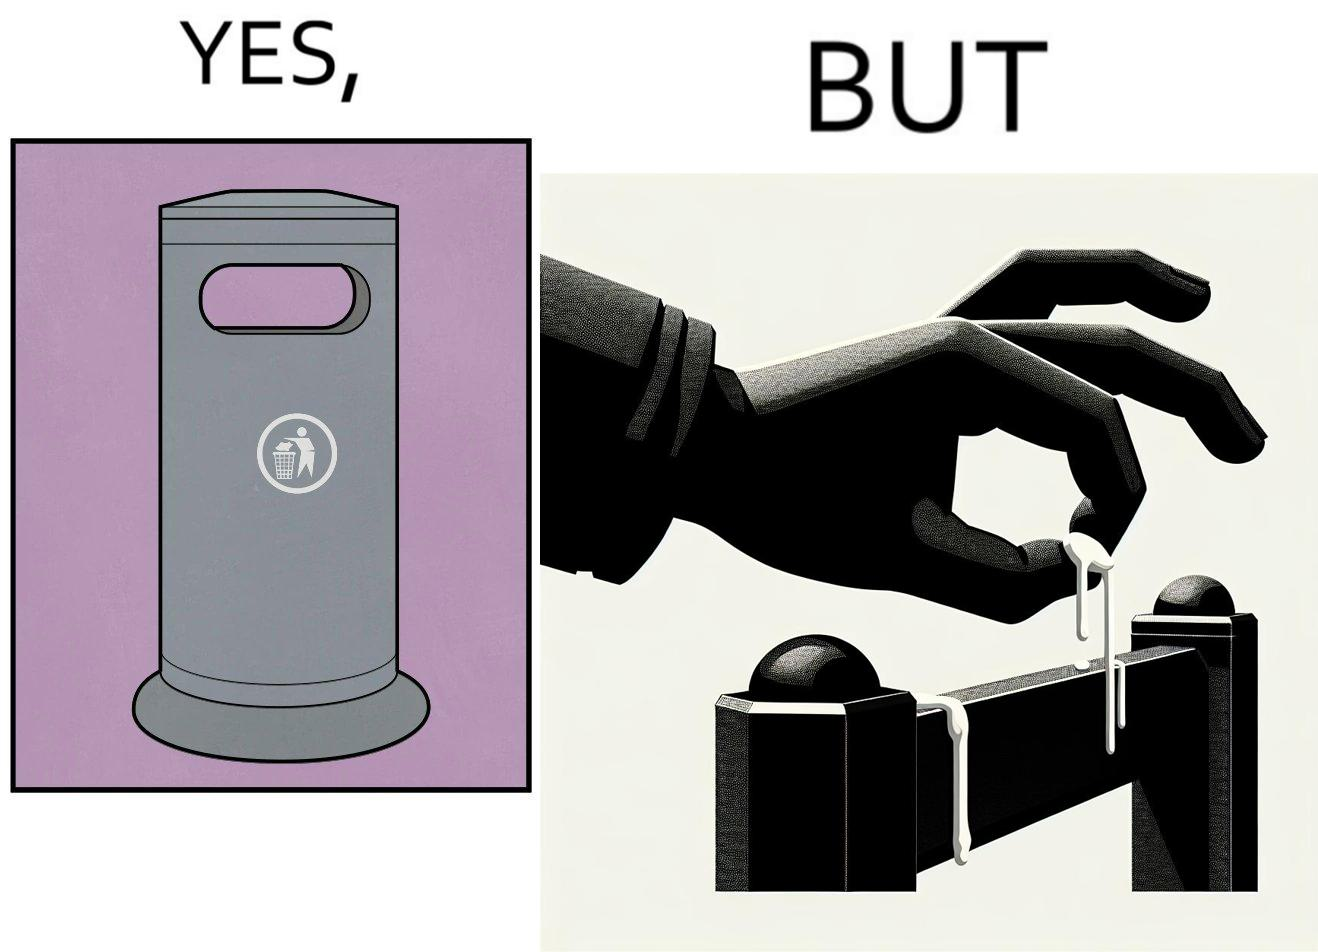Explain the humor or irony in this image. The images are ironic because even though garbage bins are provided for humans to dispose waste, by habit humans still choose to make surroundings dirty by disposing garbage improperly 